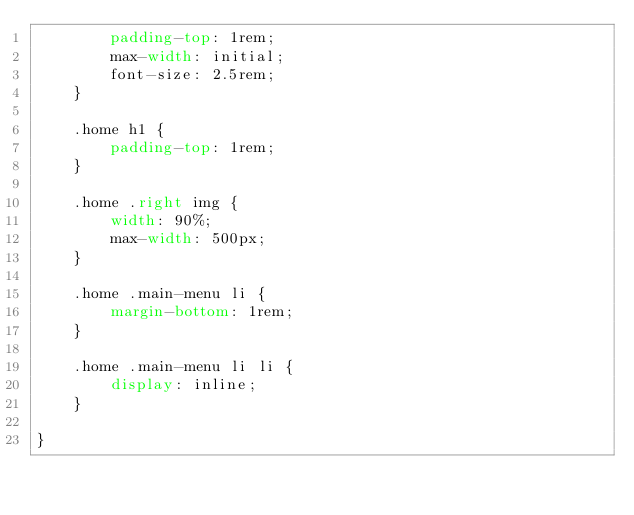<code> <loc_0><loc_0><loc_500><loc_500><_CSS_>        padding-top: 1rem;
        max-width: initial;
        font-size: 2.5rem;
    }

    .home h1 {
        padding-top: 1rem;
    }

    .home .right img {
        width: 90%;
        max-width: 500px;
    }

    .home .main-menu li {
        margin-bottom: 1rem;
    }

    .home .main-menu li li {
        display: inline;
    }

}</code> 